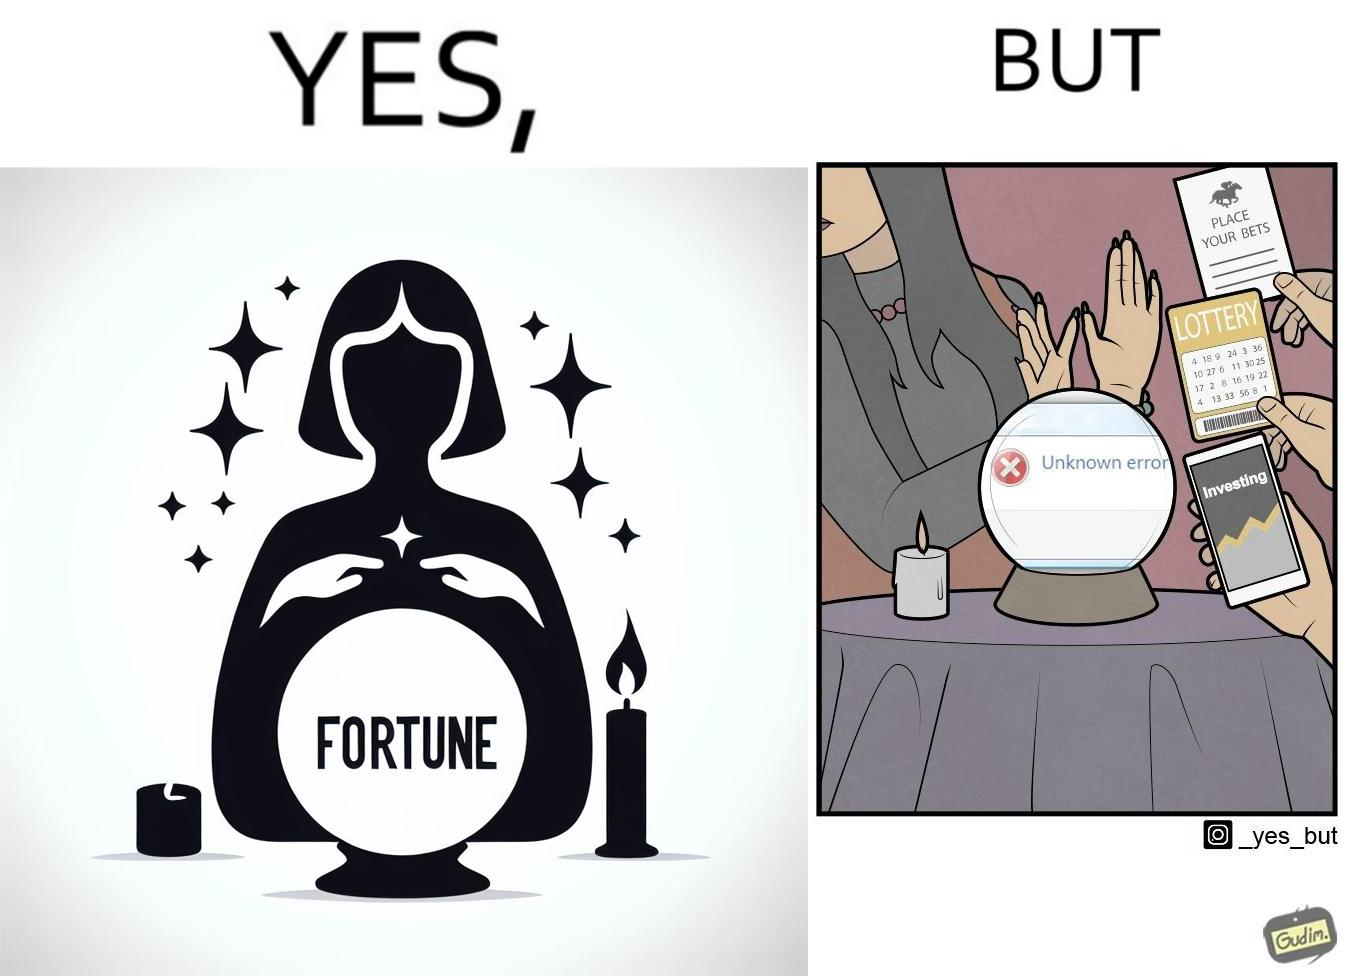Compare the left and right sides of this image. In the left part of the image: a woman dressed up as fortune teller with a candle and a fortune teller globe with "FORTUNE" written on it In the right part of the image: a woman rejecting peoples' request to predict on finance, bets and lottery as giving some "Unknown error" 